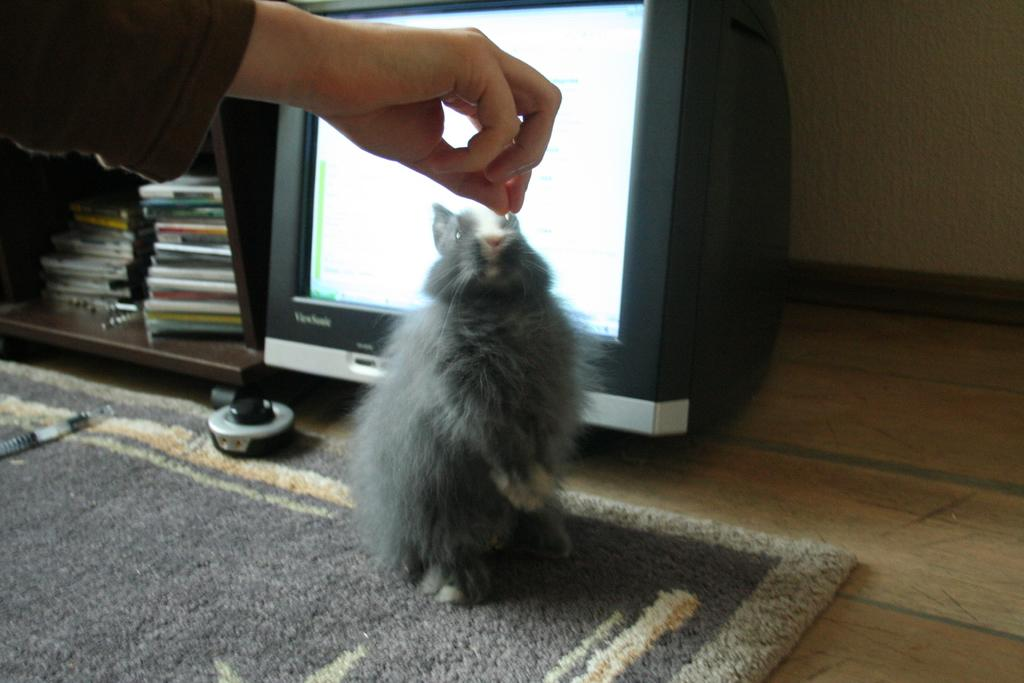What animal can be seen on the carpet in the image? There is a rabbit on the carpet in the image. What electronic device is present in the image? There is a monitor in the image. Where are the books located in the image? The books are in a cupboard in the image. What part of a person is visible in the image? A human hand is holding something in the image. What color is the paint on the square lake in the image? There is no paint, square, or lake present in the image. 